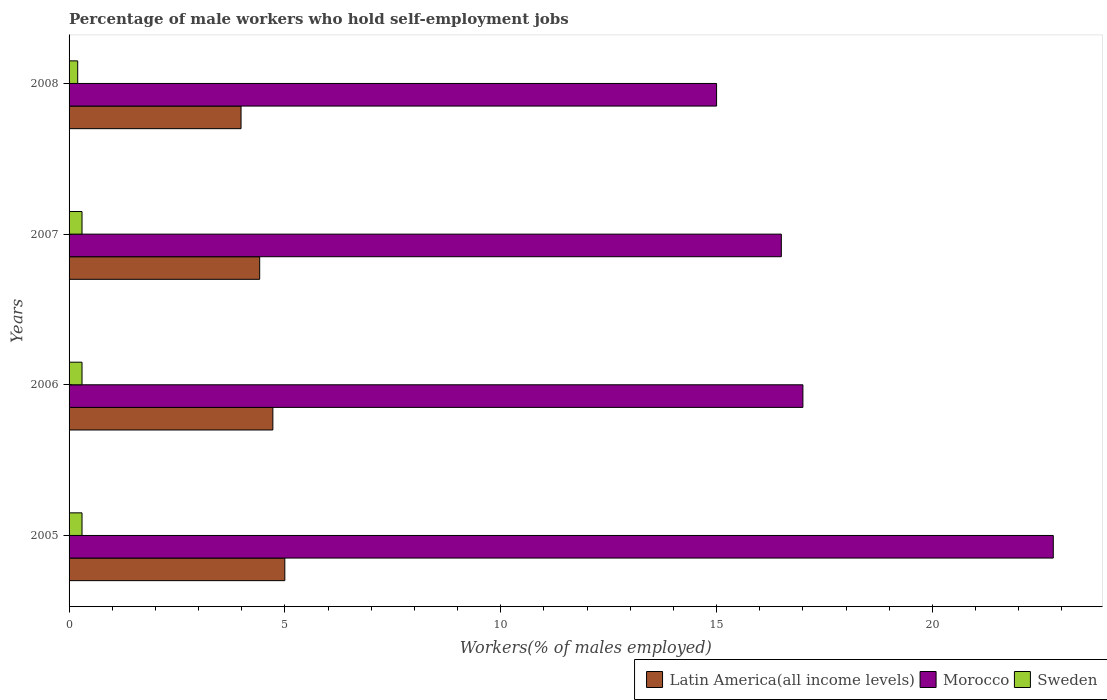How many different coloured bars are there?
Your answer should be very brief. 3. How many groups of bars are there?
Your response must be concise. 4. Are the number of bars per tick equal to the number of legend labels?
Offer a terse response. Yes. Are the number of bars on each tick of the Y-axis equal?
Offer a terse response. Yes. How many bars are there on the 4th tick from the top?
Offer a terse response. 3. How many bars are there on the 2nd tick from the bottom?
Give a very brief answer. 3. In how many cases, is the number of bars for a given year not equal to the number of legend labels?
Give a very brief answer. 0. What is the percentage of self-employed male workers in Latin America(all income levels) in 2008?
Offer a terse response. 3.98. Across all years, what is the maximum percentage of self-employed male workers in Morocco?
Make the answer very short. 22.8. Across all years, what is the minimum percentage of self-employed male workers in Sweden?
Your answer should be compact. 0.2. In which year was the percentage of self-employed male workers in Morocco minimum?
Offer a very short reply. 2008. What is the total percentage of self-employed male workers in Morocco in the graph?
Give a very brief answer. 71.3. What is the difference between the percentage of self-employed male workers in Latin America(all income levels) in 2005 and that in 2007?
Offer a very short reply. 0.58. What is the difference between the percentage of self-employed male workers in Sweden in 2008 and the percentage of self-employed male workers in Morocco in 2007?
Ensure brevity in your answer.  -16.3. What is the average percentage of self-employed male workers in Latin America(all income levels) per year?
Provide a short and direct response. 4.53. In the year 2008, what is the difference between the percentage of self-employed male workers in Morocco and percentage of self-employed male workers in Sweden?
Your answer should be very brief. 14.8. In how many years, is the percentage of self-employed male workers in Sweden greater than 8 %?
Make the answer very short. 0. What is the ratio of the percentage of self-employed male workers in Morocco in 2005 to that in 2008?
Provide a succinct answer. 1.52. What is the difference between the highest and the lowest percentage of self-employed male workers in Sweden?
Your answer should be compact. 0.1. What does the 2nd bar from the top in 2007 represents?
Offer a very short reply. Morocco. What does the 2nd bar from the bottom in 2006 represents?
Give a very brief answer. Morocco. Are all the bars in the graph horizontal?
Give a very brief answer. Yes. Does the graph contain grids?
Provide a short and direct response. No. What is the title of the graph?
Your answer should be very brief. Percentage of male workers who hold self-employment jobs. Does "Kenya" appear as one of the legend labels in the graph?
Your response must be concise. No. What is the label or title of the X-axis?
Provide a succinct answer. Workers(% of males employed). What is the label or title of the Y-axis?
Provide a short and direct response. Years. What is the Workers(% of males employed) in Latin America(all income levels) in 2005?
Offer a very short reply. 5. What is the Workers(% of males employed) of Morocco in 2005?
Keep it short and to the point. 22.8. What is the Workers(% of males employed) in Sweden in 2005?
Ensure brevity in your answer.  0.3. What is the Workers(% of males employed) in Latin America(all income levels) in 2006?
Provide a short and direct response. 4.72. What is the Workers(% of males employed) of Sweden in 2006?
Give a very brief answer. 0.3. What is the Workers(% of males employed) of Latin America(all income levels) in 2007?
Ensure brevity in your answer.  4.42. What is the Workers(% of males employed) in Sweden in 2007?
Make the answer very short. 0.3. What is the Workers(% of males employed) of Latin America(all income levels) in 2008?
Give a very brief answer. 3.98. What is the Workers(% of males employed) of Morocco in 2008?
Keep it short and to the point. 15. What is the Workers(% of males employed) in Sweden in 2008?
Keep it short and to the point. 0.2. Across all years, what is the maximum Workers(% of males employed) of Latin America(all income levels)?
Ensure brevity in your answer.  5. Across all years, what is the maximum Workers(% of males employed) in Morocco?
Keep it short and to the point. 22.8. Across all years, what is the maximum Workers(% of males employed) of Sweden?
Provide a short and direct response. 0.3. Across all years, what is the minimum Workers(% of males employed) in Latin America(all income levels)?
Provide a succinct answer. 3.98. Across all years, what is the minimum Workers(% of males employed) of Morocco?
Provide a succinct answer. 15. Across all years, what is the minimum Workers(% of males employed) of Sweden?
Offer a very short reply. 0.2. What is the total Workers(% of males employed) in Latin America(all income levels) in the graph?
Give a very brief answer. 18.12. What is the total Workers(% of males employed) of Morocco in the graph?
Your response must be concise. 71.3. What is the total Workers(% of males employed) in Sweden in the graph?
Offer a very short reply. 1.1. What is the difference between the Workers(% of males employed) in Latin America(all income levels) in 2005 and that in 2006?
Provide a short and direct response. 0.28. What is the difference between the Workers(% of males employed) in Morocco in 2005 and that in 2006?
Your response must be concise. 5.8. What is the difference between the Workers(% of males employed) in Latin America(all income levels) in 2005 and that in 2007?
Provide a short and direct response. 0.58. What is the difference between the Workers(% of males employed) in Sweden in 2005 and that in 2007?
Ensure brevity in your answer.  0. What is the difference between the Workers(% of males employed) in Latin America(all income levels) in 2005 and that in 2008?
Your answer should be compact. 1.01. What is the difference between the Workers(% of males employed) in Morocco in 2005 and that in 2008?
Provide a succinct answer. 7.8. What is the difference between the Workers(% of males employed) in Sweden in 2005 and that in 2008?
Your answer should be compact. 0.1. What is the difference between the Workers(% of males employed) of Latin America(all income levels) in 2006 and that in 2007?
Offer a terse response. 0.31. What is the difference between the Workers(% of males employed) of Sweden in 2006 and that in 2007?
Provide a short and direct response. 0. What is the difference between the Workers(% of males employed) of Latin America(all income levels) in 2006 and that in 2008?
Your answer should be very brief. 0.74. What is the difference between the Workers(% of males employed) in Latin America(all income levels) in 2007 and that in 2008?
Give a very brief answer. 0.43. What is the difference between the Workers(% of males employed) of Latin America(all income levels) in 2005 and the Workers(% of males employed) of Morocco in 2006?
Provide a succinct answer. -12. What is the difference between the Workers(% of males employed) in Latin America(all income levels) in 2005 and the Workers(% of males employed) in Sweden in 2006?
Keep it short and to the point. 4.7. What is the difference between the Workers(% of males employed) of Latin America(all income levels) in 2005 and the Workers(% of males employed) of Morocco in 2007?
Ensure brevity in your answer.  -11.5. What is the difference between the Workers(% of males employed) of Latin America(all income levels) in 2005 and the Workers(% of males employed) of Sweden in 2007?
Give a very brief answer. 4.7. What is the difference between the Workers(% of males employed) in Morocco in 2005 and the Workers(% of males employed) in Sweden in 2007?
Ensure brevity in your answer.  22.5. What is the difference between the Workers(% of males employed) in Latin America(all income levels) in 2005 and the Workers(% of males employed) in Morocco in 2008?
Make the answer very short. -10. What is the difference between the Workers(% of males employed) of Latin America(all income levels) in 2005 and the Workers(% of males employed) of Sweden in 2008?
Make the answer very short. 4.8. What is the difference between the Workers(% of males employed) in Morocco in 2005 and the Workers(% of males employed) in Sweden in 2008?
Keep it short and to the point. 22.6. What is the difference between the Workers(% of males employed) of Latin America(all income levels) in 2006 and the Workers(% of males employed) of Morocco in 2007?
Ensure brevity in your answer.  -11.78. What is the difference between the Workers(% of males employed) of Latin America(all income levels) in 2006 and the Workers(% of males employed) of Sweden in 2007?
Your answer should be very brief. 4.42. What is the difference between the Workers(% of males employed) in Morocco in 2006 and the Workers(% of males employed) in Sweden in 2007?
Give a very brief answer. 16.7. What is the difference between the Workers(% of males employed) of Latin America(all income levels) in 2006 and the Workers(% of males employed) of Morocco in 2008?
Your answer should be very brief. -10.28. What is the difference between the Workers(% of males employed) of Latin America(all income levels) in 2006 and the Workers(% of males employed) of Sweden in 2008?
Keep it short and to the point. 4.52. What is the difference between the Workers(% of males employed) of Morocco in 2006 and the Workers(% of males employed) of Sweden in 2008?
Your response must be concise. 16.8. What is the difference between the Workers(% of males employed) of Latin America(all income levels) in 2007 and the Workers(% of males employed) of Morocco in 2008?
Your answer should be compact. -10.58. What is the difference between the Workers(% of males employed) of Latin America(all income levels) in 2007 and the Workers(% of males employed) of Sweden in 2008?
Offer a terse response. 4.22. What is the difference between the Workers(% of males employed) of Morocco in 2007 and the Workers(% of males employed) of Sweden in 2008?
Keep it short and to the point. 16.3. What is the average Workers(% of males employed) of Latin America(all income levels) per year?
Ensure brevity in your answer.  4.53. What is the average Workers(% of males employed) of Morocco per year?
Offer a terse response. 17.82. What is the average Workers(% of males employed) in Sweden per year?
Keep it short and to the point. 0.28. In the year 2005, what is the difference between the Workers(% of males employed) of Latin America(all income levels) and Workers(% of males employed) of Morocco?
Make the answer very short. -17.8. In the year 2005, what is the difference between the Workers(% of males employed) of Latin America(all income levels) and Workers(% of males employed) of Sweden?
Offer a terse response. 4.7. In the year 2005, what is the difference between the Workers(% of males employed) of Morocco and Workers(% of males employed) of Sweden?
Provide a succinct answer. 22.5. In the year 2006, what is the difference between the Workers(% of males employed) of Latin America(all income levels) and Workers(% of males employed) of Morocco?
Your answer should be very brief. -12.28. In the year 2006, what is the difference between the Workers(% of males employed) in Latin America(all income levels) and Workers(% of males employed) in Sweden?
Offer a very short reply. 4.42. In the year 2007, what is the difference between the Workers(% of males employed) in Latin America(all income levels) and Workers(% of males employed) in Morocco?
Provide a short and direct response. -12.08. In the year 2007, what is the difference between the Workers(% of males employed) of Latin America(all income levels) and Workers(% of males employed) of Sweden?
Make the answer very short. 4.12. In the year 2007, what is the difference between the Workers(% of males employed) in Morocco and Workers(% of males employed) in Sweden?
Your answer should be very brief. 16.2. In the year 2008, what is the difference between the Workers(% of males employed) of Latin America(all income levels) and Workers(% of males employed) of Morocco?
Make the answer very short. -11.02. In the year 2008, what is the difference between the Workers(% of males employed) of Latin America(all income levels) and Workers(% of males employed) of Sweden?
Give a very brief answer. 3.78. What is the ratio of the Workers(% of males employed) in Latin America(all income levels) in 2005 to that in 2006?
Give a very brief answer. 1.06. What is the ratio of the Workers(% of males employed) of Morocco in 2005 to that in 2006?
Ensure brevity in your answer.  1.34. What is the ratio of the Workers(% of males employed) in Latin America(all income levels) in 2005 to that in 2007?
Make the answer very short. 1.13. What is the ratio of the Workers(% of males employed) in Morocco in 2005 to that in 2007?
Ensure brevity in your answer.  1.38. What is the ratio of the Workers(% of males employed) in Latin America(all income levels) in 2005 to that in 2008?
Keep it short and to the point. 1.25. What is the ratio of the Workers(% of males employed) of Morocco in 2005 to that in 2008?
Provide a short and direct response. 1.52. What is the ratio of the Workers(% of males employed) of Sweden in 2005 to that in 2008?
Give a very brief answer. 1.5. What is the ratio of the Workers(% of males employed) of Latin America(all income levels) in 2006 to that in 2007?
Keep it short and to the point. 1.07. What is the ratio of the Workers(% of males employed) in Morocco in 2006 to that in 2007?
Offer a terse response. 1.03. What is the ratio of the Workers(% of males employed) in Latin America(all income levels) in 2006 to that in 2008?
Give a very brief answer. 1.18. What is the ratio of the Workers(% of males employed) of Morocco in 2006 to that in 2008?
Your response must be concise. 1.13. What is the ratio of the Workers(% of males employed) in Sweden in 2006 to that in 2008?
Your answer should be very brief. 1.5. What is the ratio of the Workers(% of males employed) in Latin America(all income levels) in 2007 to that in 2008?
Give a very brief answer. 1.11. What is the difference between the highest and the second highest Workers(% of males employed) of Latin America(all income levels)?
Offer a terse response. 0.28. What is the difference between the highest and the second highest Workers(% of males employed) of Morocco?
Your response must be concise. 5.8. What is the difference between the highest and the second highest Workers(% of males employed) of Sweden?
Keep it short and to the point. 0. What is the difference between the highest and the lowest Workers(% of males employed) of Latin America(all income levels)?
Your answer should be very brief. 1.01. What is the difference between the highest and the lowest Workers(% of males employed) in Morocco?
Offer a terse response. 7.8. 